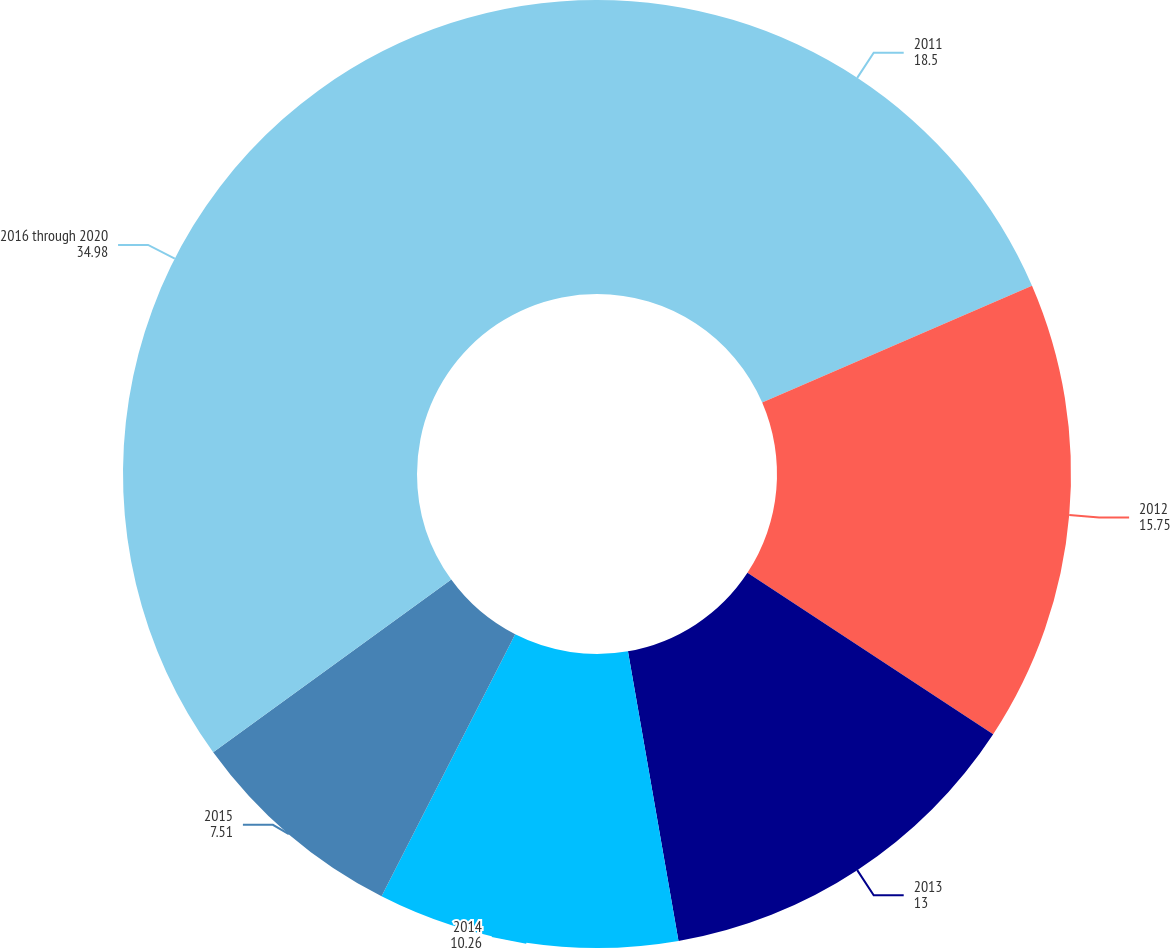Convert chart. <chart><loc_0><loc_0><loc_500><loc_500><pie_chart><fcel>2011<fcel>2012<fcel>2013<fcel>2014<fcel>2015<fcel>2016 through 2020<nl><fcel>18.5%<fcel>15.75%<fcel>13.0%<fcel>10.26%<fcel>7.51%<fcel>34.98%<nl></chart> 